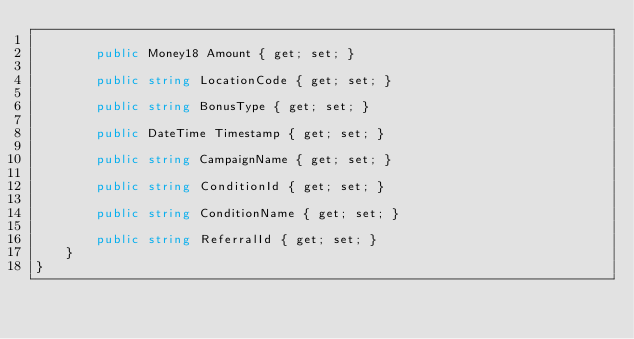Convert code to text. <code><loc_0><loc_0><loc_500><loc_500><_C#_>
        public Money18 Amount { get; set; }

        public string LocationCode { get; set; }

        public string BonusType { get; set; }

        public DateTime Timestamp { get; set; }

        public string CampaignName { get; set; }

        public string ConditionId { get; set; }

        public string ConditionName { get; set; }

        public string ReferralId { get; set; }
    }
}
</code> 